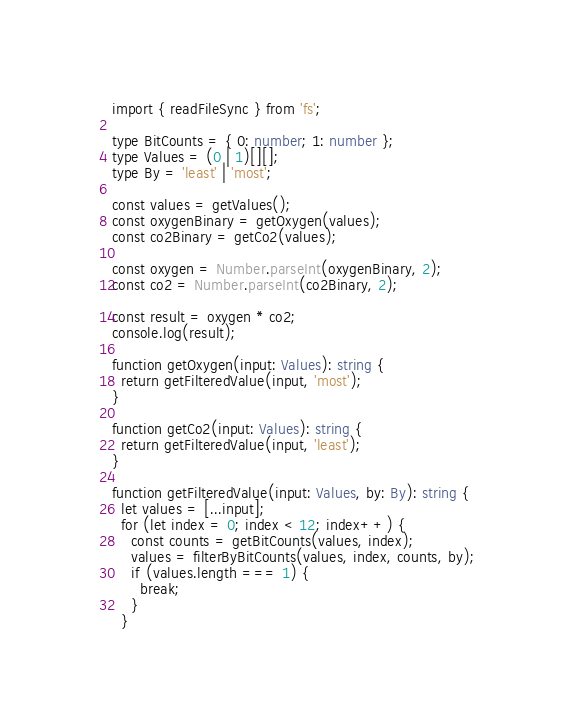<code> <loc_0><loc_0><loc_500><loc_500><_TypeScript_>import { readFileSync } from 'fs';

type BitCounts = { 0: number; 1: number };
type Values = (0 | 1)[][];
type By = 'least' | 'most';

const values = getValues();
const oxygenBinary = getOxygen(values);
const co2Binary = getCo2(values);

const oxygen = Number.parseInt(oxygenBinary, 2);
const co2 = Number.parseInt(co2Binary, 2);

const result = oxygen * co2;
console.log(result);

function getOxygen(input: Values): string {
  return getFilteredValue(input, 'most');
}

function getCo2(input: Values): string {
  return getFilteredValue(input, 'least');
}

function getFilteredValue(input: Values, by: By): string {
  let values = [...input];
  for (let index = 0; index < 12; index++) {
    const counts = getBitCounts(values, index);
    values = filterByBitCounts(values, index, counts, by);
    if (values.length === 1) {
      break;
    }
  }</code> 